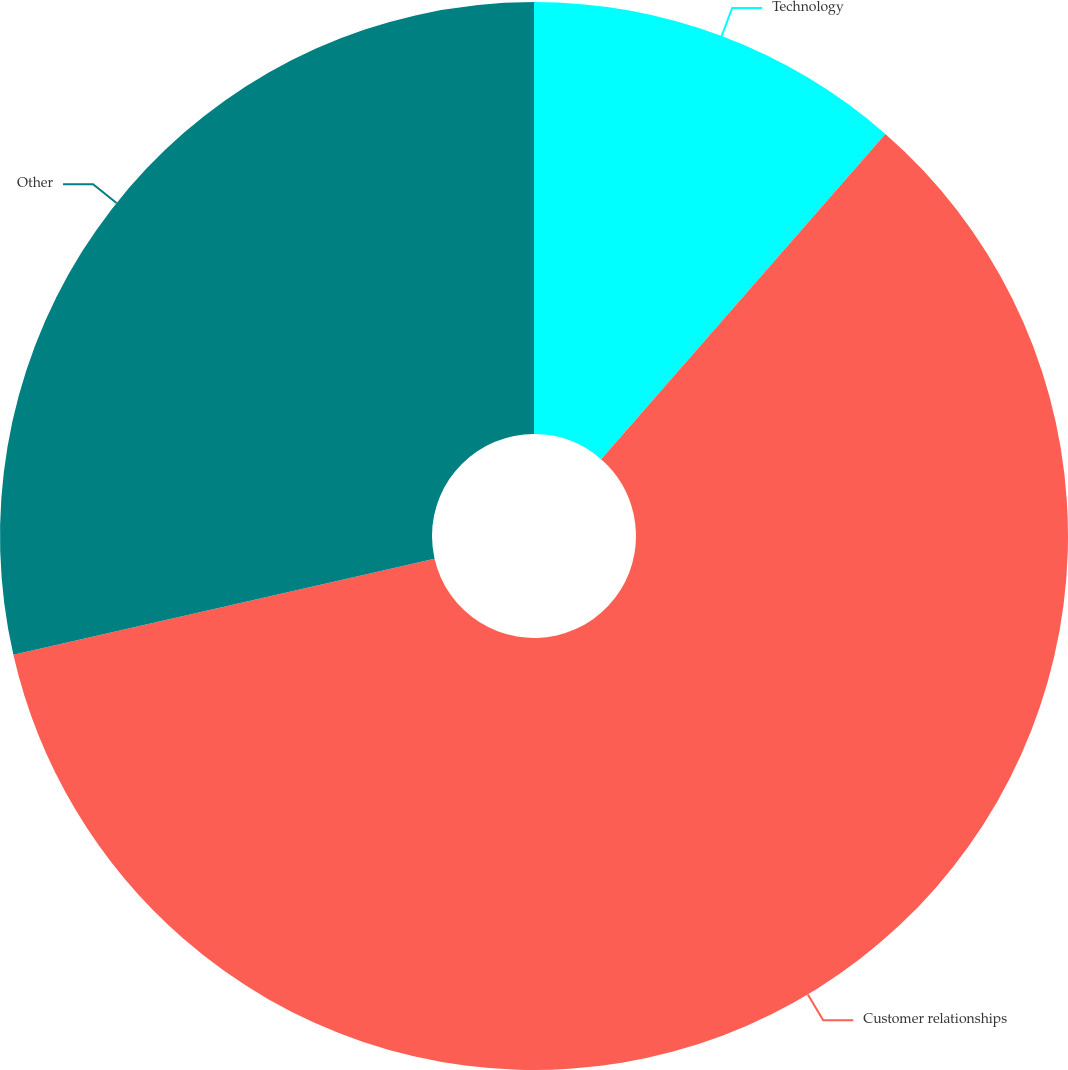Convert chart. <chart><loc_0><loc_0><loc_500><loc_500><pie_chart><fcel>Technology<fcel>Customer relationships<fcel>Other<nl><fcel>11.43%<fcel>60.0%<fcel>28.57%<nl></chart> 